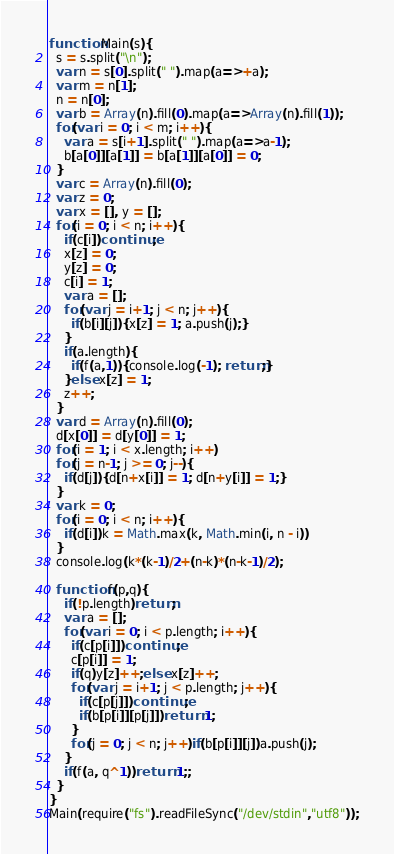<code> <loc_0><loc_0><loc_500><loc_500><_JavaScript_>function Main(s){
  s = s.split("\n");
  var n = s[0].split(" ").map(a=>+a);
  var m = n[1];
  n = n[0];
  var b = Array(n).fill(0).map(a=>Array(n).fill(1));
  for(var i = 0; i < m; i++){
    var a = s[i+1].split(" ").map(a=>a-1);
    b[a[0]][a[1]] = b[a[1]][a[0]] = 0;
  }
  var c = Array(n).fill(0);
  var z = 0;
  var x = [], y = [];
  for(i = 0; i < n; i++){
    if(c[i])continue;
    x[z] = 0;
    y[z] = 0;
    c[i] = 1;
    var a = [];
    for(var j = i+1; j < n; j++){
      if(b[i][j]){x[z] = 1; a.push(j);}
    }
    if(a.length){
      if(f(a,1)){console.log(-1); return;}
    }else x[z] = 1;
    z++;
  }
  var d = Array(n).fill(0);
  d[x[0]] = d[y[0]] = 1;
  for(i = 1; i < x.length; i++)
  for(j = n-1; j >= 0; j--){
    if(d[j]){d[n+x[i]] = 1; d[n+y[i]] = 1;}
  }
  var k = 0;
  for(i = 0; i < n; i++){
    if(d[i])k = Math.max(k, Math.min(i, n - i))
  }
  console.log(k*(k-1)/2+(n-k)*(n-k-1)/2);
  
  function f(p,q){
    if(!p.length)return;
    var a = [];
    for(var i = 0; i < p.length; i++){
      if(c[p[i]])continue;
      c[p[i]] = 1;
      if(q)y[z]++;else x[z]++;
      for(var j = i+1; j < p.length; j++){
        if(c[p[j]])continue;
        if(b[p[i]][p[j]])return 1;
      }
      for(j = 0; j < n; j++)if(b[p[i]][j])a.push(j);
    }
    if(f(a, q^1))return 1;;
  }
}
Main(require("fs").readFileSync("/dev/stdin","utf8"));</code> 